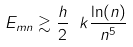Convert formula to latex. <formula><loc_0><loc_0><loc_500><loc_500>E _ { m n } \gtrsim \frac { h } { 2 } \text { } k \frac { \ln ( n ) } { n ^ { 5 } }</formula> 